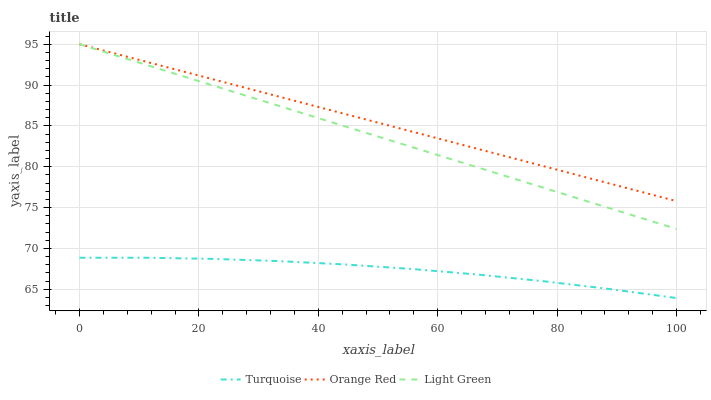Does Turquoise have the minimum area under the curve?
Answer yes or no. Yes. Does Orange Red have the maximum area under the curve?
Answer yes or no. Yes. Does Light Green have the minimum area under the curve?
Answer yes or no. No. Does Light Green have the maximum area under the curve?
Answer yes or no. No. Is Orange Red the smoothest?
Answer yes or no. Yes. Is Turquoise the roughest?
Answer yes or no. Yes. Is Light Green the smoothest?
Answer yes or no. No. Is Light Green the roughest?
Answer yes or no. No. Does Light Green have the lowest value?
Answer yes or no. No. Does Light Green have the highest value?
Answer yes or no. Yes. Is Turquoise less than Light Green?
Answer yes or no. Yes. Is Orange Red greater than Turquoise?
Answer yes or no. Yes. Does Turquoise intersect Light Green?
Answer yes or no. No. 